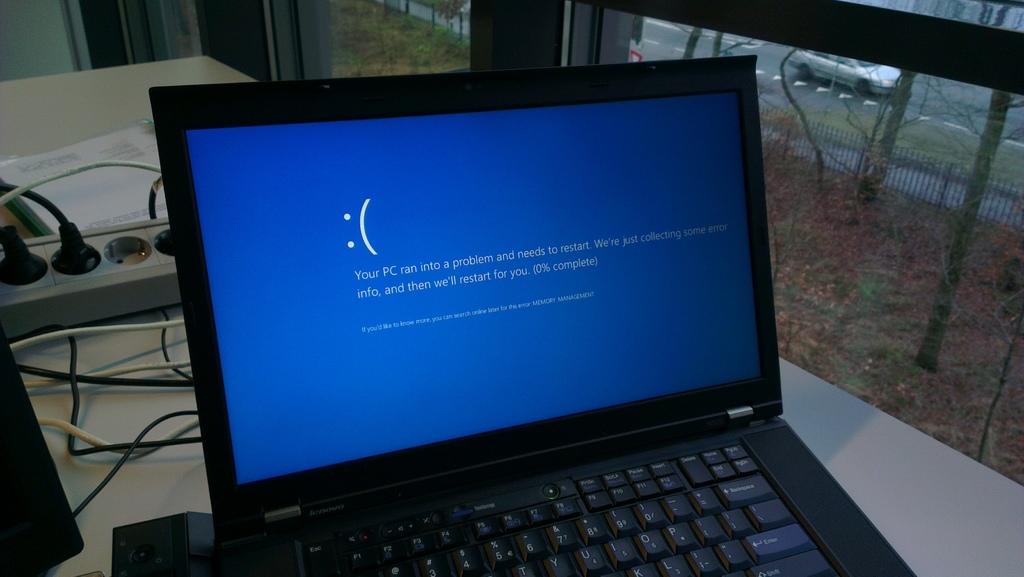What does the pc need to do?
Provide a short and direct response. Restart. What is written on the blue button?
Your answer should be very brief. Enter. 